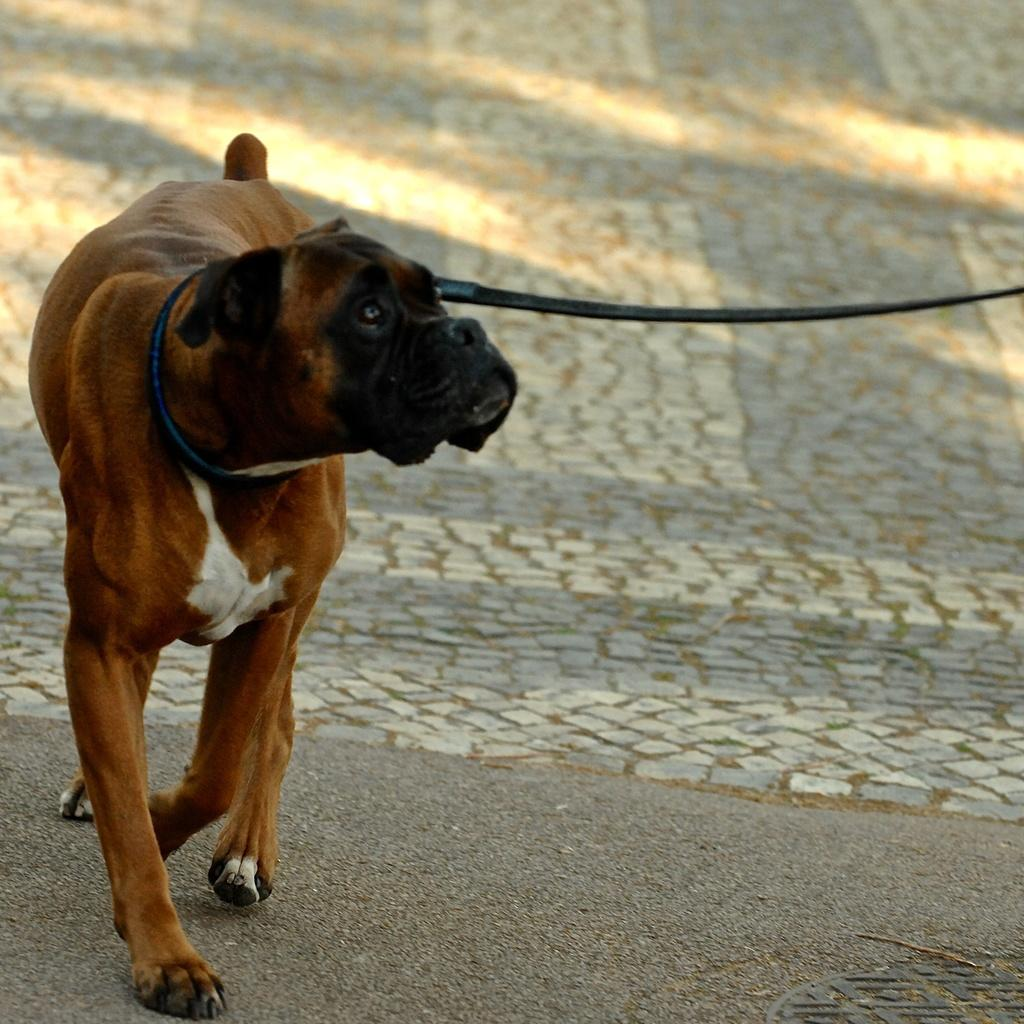What animal can be seen in the image? There is a dog in the image. What is the dog doing in the image? The dog is walking on the floor. Is there any accessory or equipment related to the dog in the image? Yes, there is a dog belt in the image. What color is the throne in the image? There is no throne present in the image. What type of toy is the dog playing with in the image? There is no toy visible in the image; the dog is simply walking on the floor. 